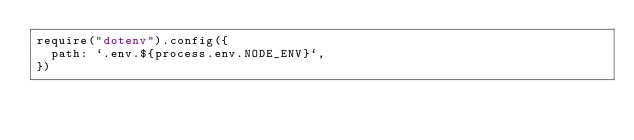<code> <loc_0><loc_0><loc_500><loc_500><_JavaScript_>require("dotenv").config({
  path: `.env.${process.env.NODE_ENV}`,
})
</code> 